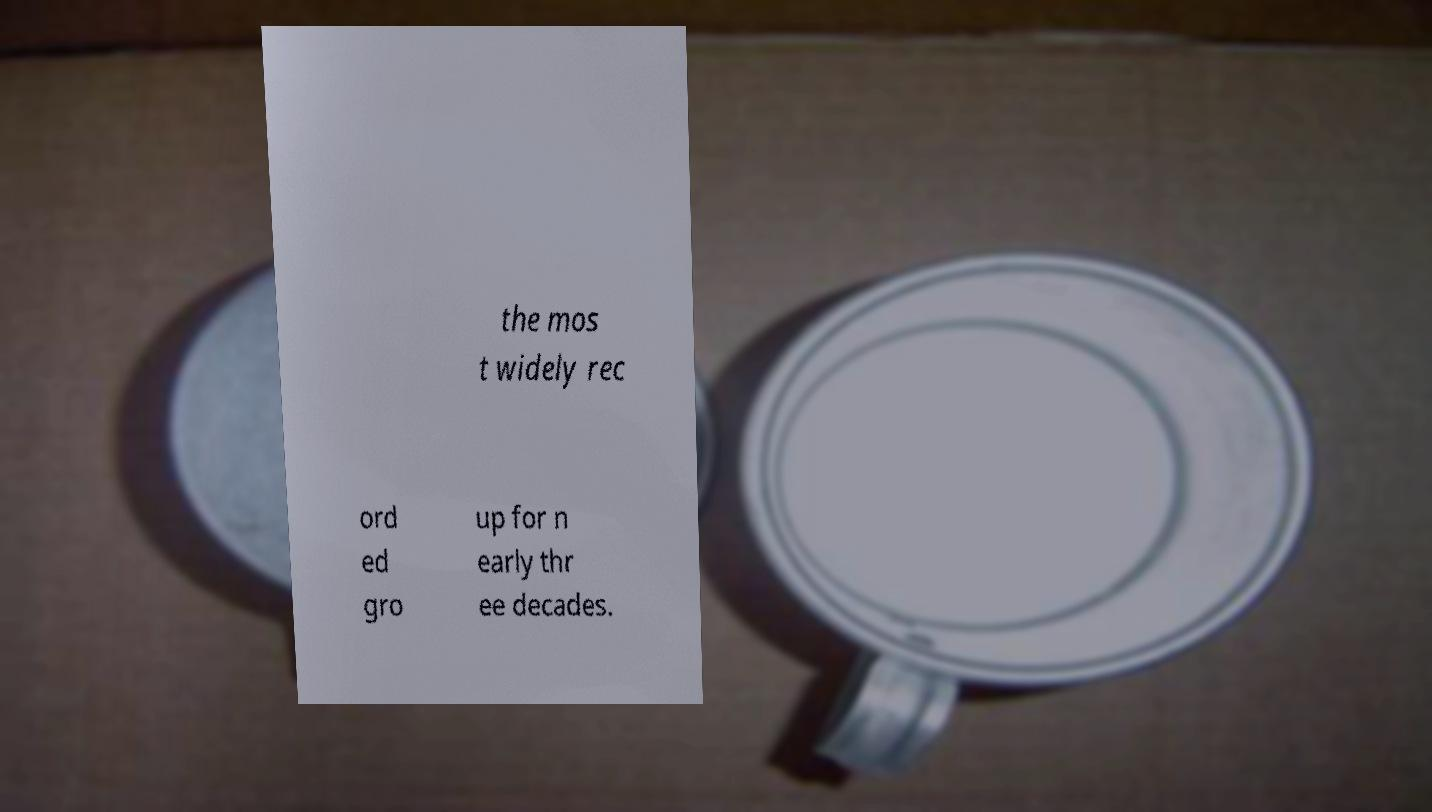Can you read and provide the text displayed in the image?This photo seems to have some interesting text. Can you extract and type it out for me? the mos t widely rec ord ed gro up for n early thr ee decades. 